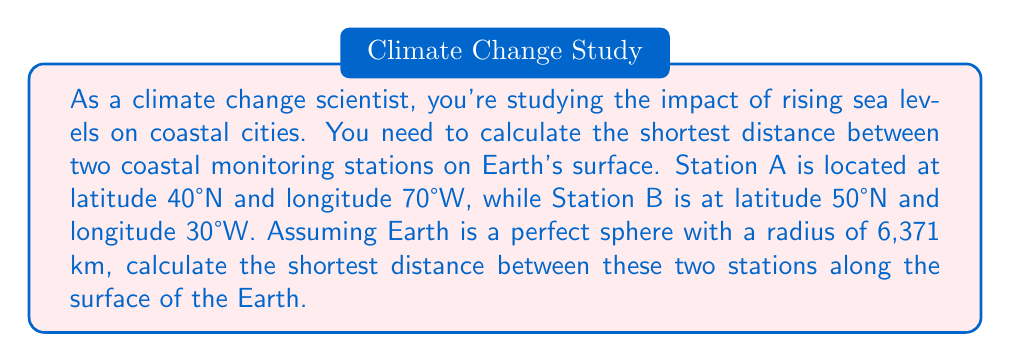Help me with this question. To solve this problem, we'll use the spherical law of cosines formula for great circle distances. Here's the step-by-step solution:

1) Convert the latitudes and longitudes to radians:
   $\phi_1 = 40° \times \frac{\pi}{180°} = 0.6981$ radians
   $\lambda_1 = -70° \times \frac{\pi}{180°} = -1.2217$ radians
   $\phi_2 = 50° \times \frac{\pi}{180°} = 0.8727$ radians
   $\lambda_2 = -30° \times \frac{\pi}{180°} = -0.5236$ radians

2) Use the spherical law of cosines formula:
   $$\cos(c) = \sin(\phi_1)\sin(\phi_2) + \cos(\phi_1)\cos(\phi_2)\cos(\lambda_2 - \lambda_1)$$
   
   Where $c$ is the central angle between the two points.

3) Substitute the values:
   $$\cos(c) = \sin(0.6981)\sin(0.8727) + \cos(0.6981)\cos(0.8727)\cos(-0.5236 - (-1.2217))$$

4) Simplify:
   $$\cos(c) = (0.6428)(0.7660) + (0.7660)(0.6428)(0.7660) = 0.4924 + 0.3771 = 0.8695$$

5) Take the inverse cosine (arccos) of both sides:
   $$c = \arccos(0.8695) = 0.5123 \text{ radians}$$

6) Calculate the distance along the Earth's surface:
   $$d = R \times c$$
   Where $R$ is the radius of the Earth (6,371 km)
   
   $$d = 6371 \times 0.5123 = 3263.76 \text{ km}$$

[asy]
import geometry;

size(200);
draw(Circle((0,0),1));
dot((0.766,0.6428));
dot((0.4924,0.8695));
draw((0,0)--(0.766,0.6428),dashed);
draw((0,0)--(0.4924,0.8695),dashed);
draw(arc((0,0),1,50,130));
label("A",(0.766,0.6428),SE);
label("B",(0.4924,0.8695),NE);
label("$c$",(0.4,0.5),NW);
[/asy]
Answer: The shortest distance between the two coastal monitoring stations along the surface of the Earth is approximately 3,264 km. 